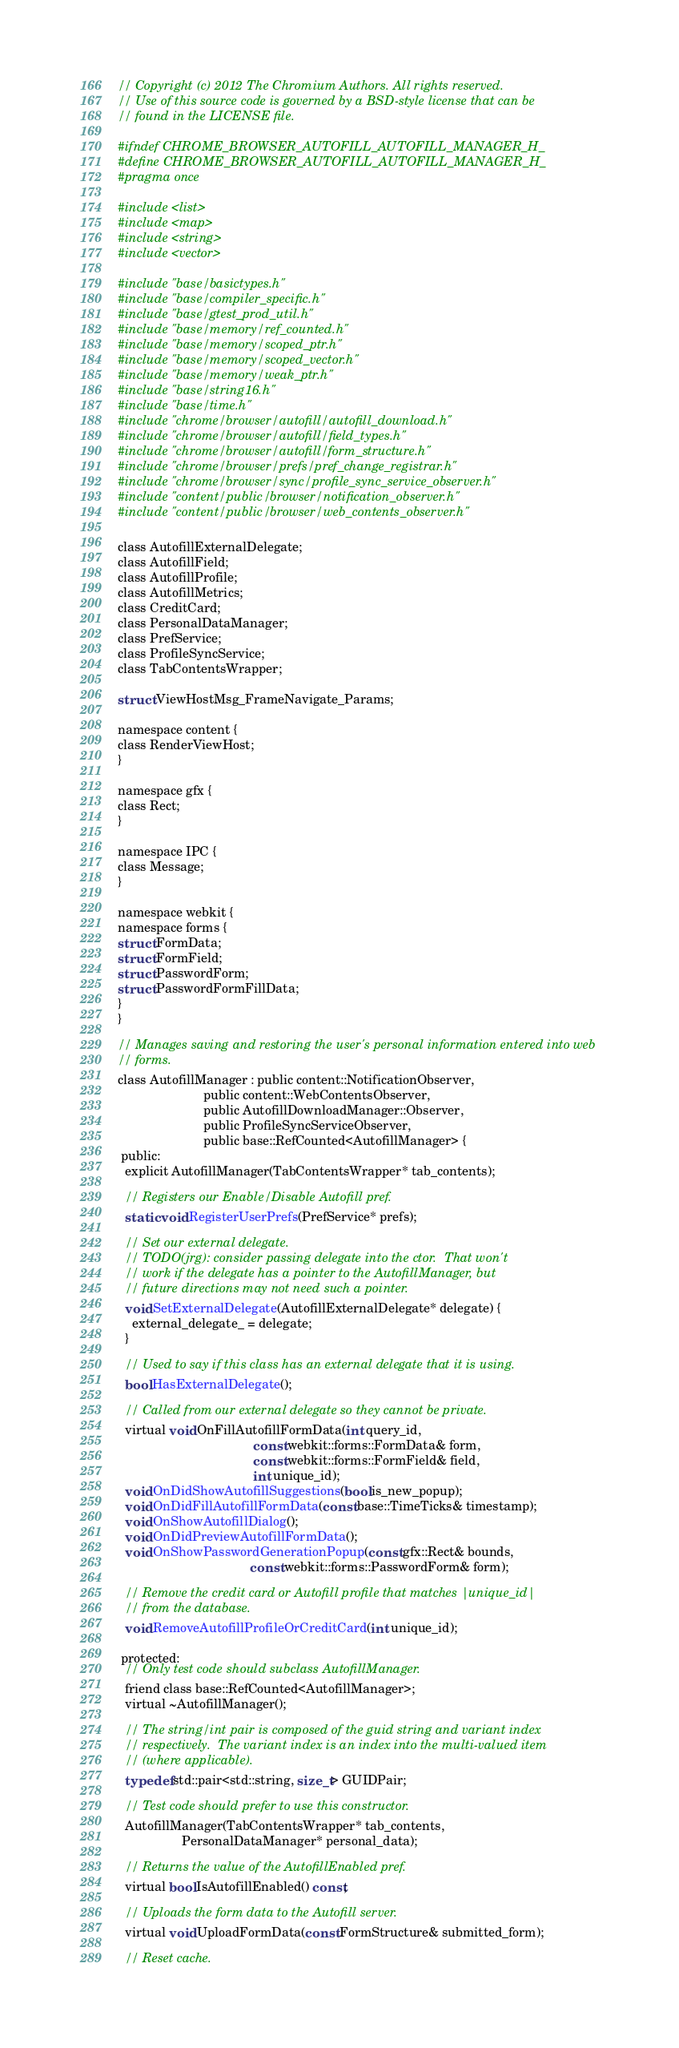<code> <loc_0><loc_0><loc_500><loc_500><_C_>// Copyright (c) 2012 The Chromium Authors. All rights reserved.
// Use of this source code is governed by a BSD-style license that can be
// found in the LICENSE file.

#ifndef CHROME_BROWSER_AUTOFILL_AUTOFILL_MANAGER_H_
#define CHROME_BROWSER_AUTOFILL_AUTOFILL_MANAGER_H_
#pragma once

#include <list>
#include <map>
#include <string>
#include <vector>

#include "base/basictypes.h"
#include "base/compiler_specific.h"
#include "base/gtest_prod_util.h"
#include "base/memory/ref_counted.h"
#include "base/memory/scoped_ptr.h"
#include "base/memory/scoped_vector.h"
#include "base/memory/weak_ptr.h"
#include "base/string16.h"
#include "base/time.h"
#include "chrome/browser/autofill/autofill_download.h"
#include "chrome/browser/autofill/field_types.h"
#include "chrome/browser/autofill/form_structure.h"
#include "chrome/browser/prefs/pref_change_registrar.h"
#include "chrome/browser/sync/profile_sync_service_observer.h"
#include "content/public/browser/notification_observer.h"
#include "content/public/browser/web_contents_observer.h"

class AutofillExternalDelegate;
class AutofillField;
class AutofillProfile;
class AutofillMetrics;
class CreditCard;
class PersonalDataManager;
class PrefService;
class ProfileSyncService;
class TabContentsWrapper;

struct ViewHostMsg_FrameNavigate_Params;

namespace content {
class RenderViewHost;
}

namespace gfx {
class Rect;
}

namespace IPC {
class Message;
}

namespace webkit {
namespace forms {
struct FormData;
struct FormField;
struct PasswordForm;
struct PasswordFormFillData;
}
}

// Manages saving and restoring the user's personal information entered into web
// forms.
class AutofillManager : public content::NotificationObserver,
                        public content::WebContentsObserver,
                        public AutofillDownloadManager::Observer,
                        public ProfileSyncServiceObserver,
                        public base::RefCounted<AutofillManager> {
 public:
  explicit AutofillManager(TabContentsWrapper* tab_contents);

  // Registers our Enable/Disable Autofill pref.
  static void RegisterUserPrefs(PrefService* prefs);

  // Set our external delegate.
  // TODO(jrg): consider passing delegate into the ctor.  That won't
  // work if the delegate has a pointer to the AutofillManager, but
  // future directions may not need such a pointer.
  void SetExternalDelegate(AutofillExternalDelegate* delegate) {
    external_delegate_ = delegate;
  }

  // Used to say if this class has an external delegate that it is using.
  bool HasExternalDelegate();

  // Called from our external delegate so they cannot be private.
  virtual void OnFillAutofillFormData(int query_id,
                                      const webkit::forms::FormData& form,
                                      const webkit::forms::FormField& field,
                                      int unique_id);
  void OnDidShowAutofillSuggestions(bool is_new_popup);
  void OnDidFillAutofillFormData(const base::TimeTicks& timestamp);
  void OnShowAutofillDialog();
  void OnDidPreviewAutofillFormData();
  void OnShowPasswordGenerationPopup(const gfx::Rect& bounds,
                                     const webkit::forms::PasswordForm& form);

  // Remove the credit card or Autofill profile that matches |unique_id|
  // from the database.
  void RemoveAutofillProfileOrCreditCard(int unique_id);

 protected:
  // Only test code should subclass AutofillManager.
  friend class base::RefCounted<AutofillManager>;
  virtual ~AutofillManager();

  // The string/int pair is composed of the guid string and variant index
  // respectively.  The variant index is an index into the multi-valued item
  // (where applicable).
  typedef std::pair<std::string, size_t> GUIDPair;

  // Test code should prefer to use this constructor.
  AutofillManager(TabContentsWrapper* tab_contents,
                  PersonalDataManager* personal_data);

  // Returns the value of the AutofillEnabled pref.
  virtual bool IsAutofillEnabled() const;

  // Uploads the form data to the Autofill server.
  virtual void UploadFormData(const FormStructure& submitted_form);

  // Reset cache.</code> 